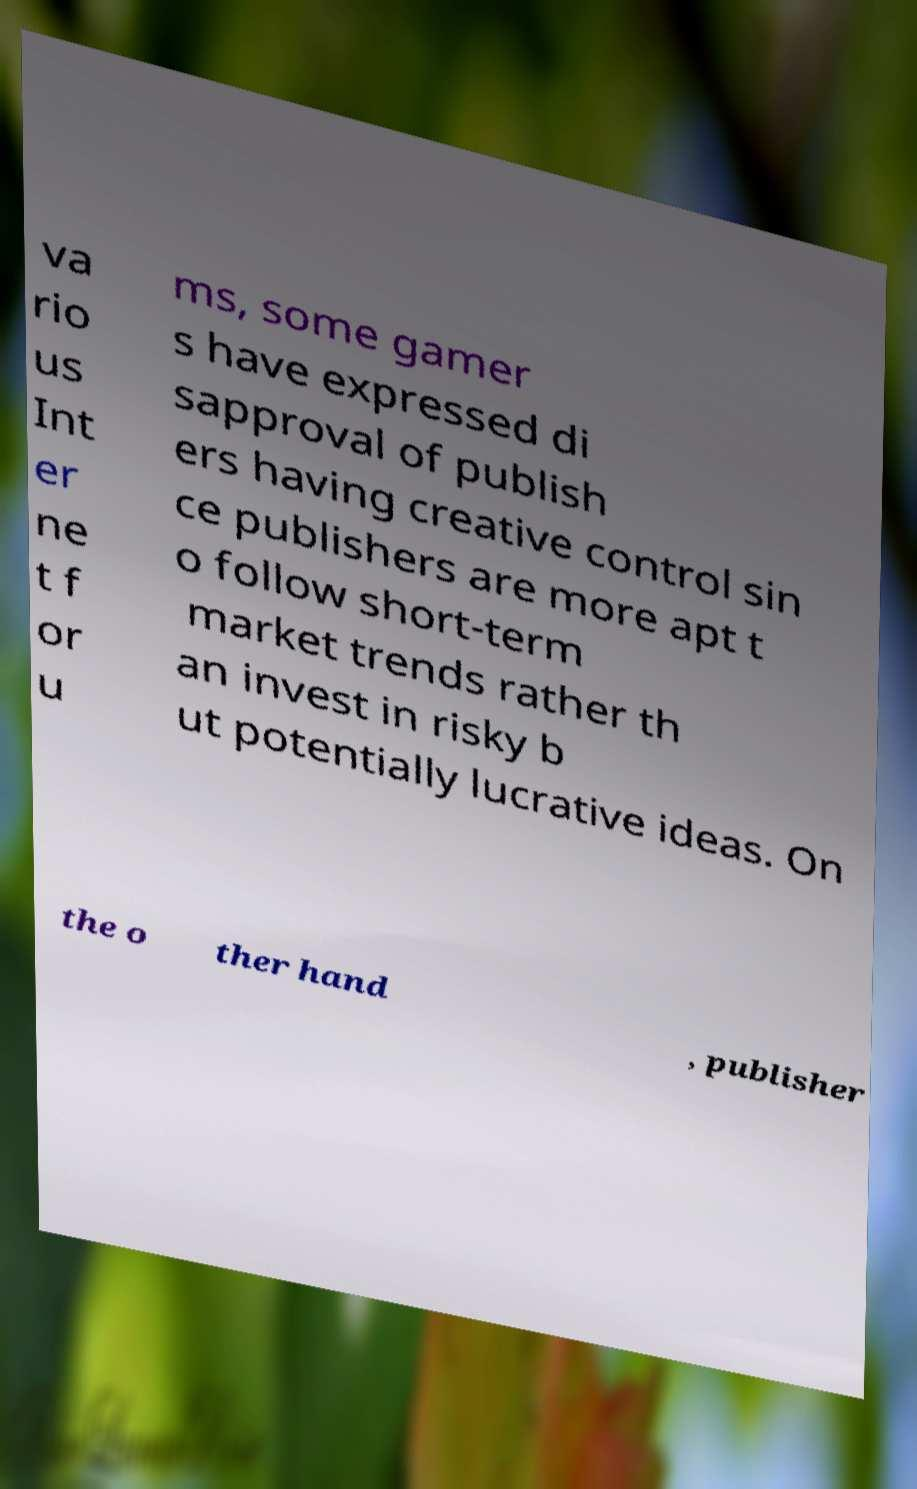Please read and relay the text visible in this image. What does it say? va rio us Int er ne t f or u ms, some gamer s have expressed di sapproval of publish ers having creative control sin ce publishers are more apt t o follow short-term market trends rather th an invest in risky b ut potentially lucrative ideas. On the o ther hand , publisher 